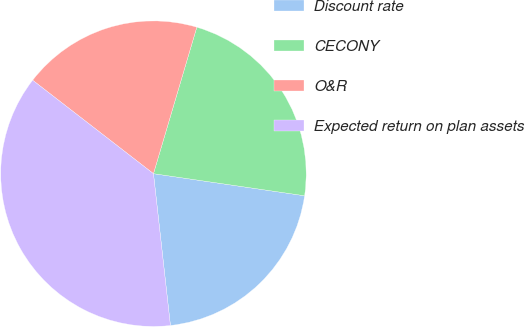Convert chart to OTSL. <chart><loc_0><loc_0><loc_500><loc_500><pie_chart><fcel>Discount rate<fcel>CECONY<fcel>O&R<fcel>Expected return on plan assets<nl><fcel>20.92%<fcel>22.73%<fcel>19.1%<fcel>37.25%<nl></chart> 